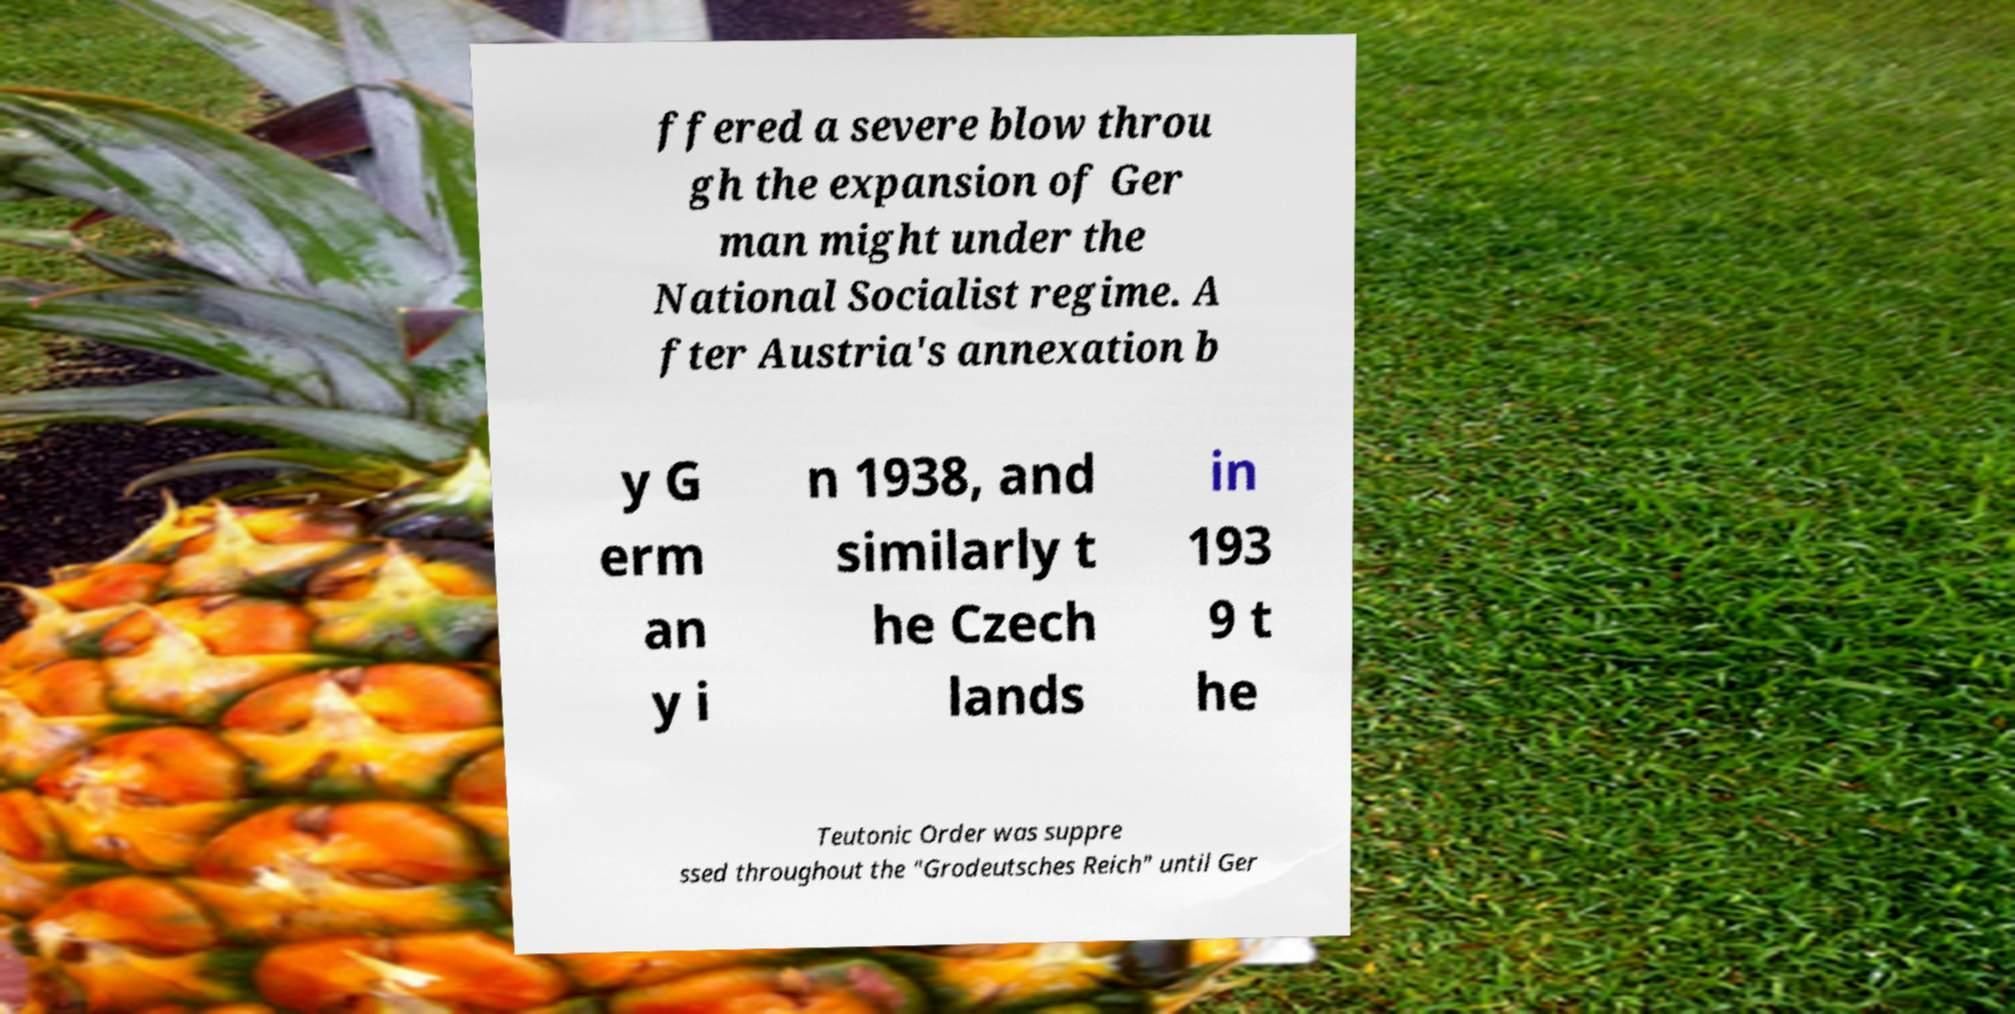Can you read and provide the text displayed in the image?This photo seems to have some interesting text. Can you extract and type it out for me? ffered a severe blow throu gh the expansion of Ger man might under the National Socialist regime. A fter Austria's annexation b y G erm an y i n 1938, and similarly t he Czech lands in 193 9 t he Teutonic Order was suppre ssed throughout the "Grodeutsches Reich" until Ger 